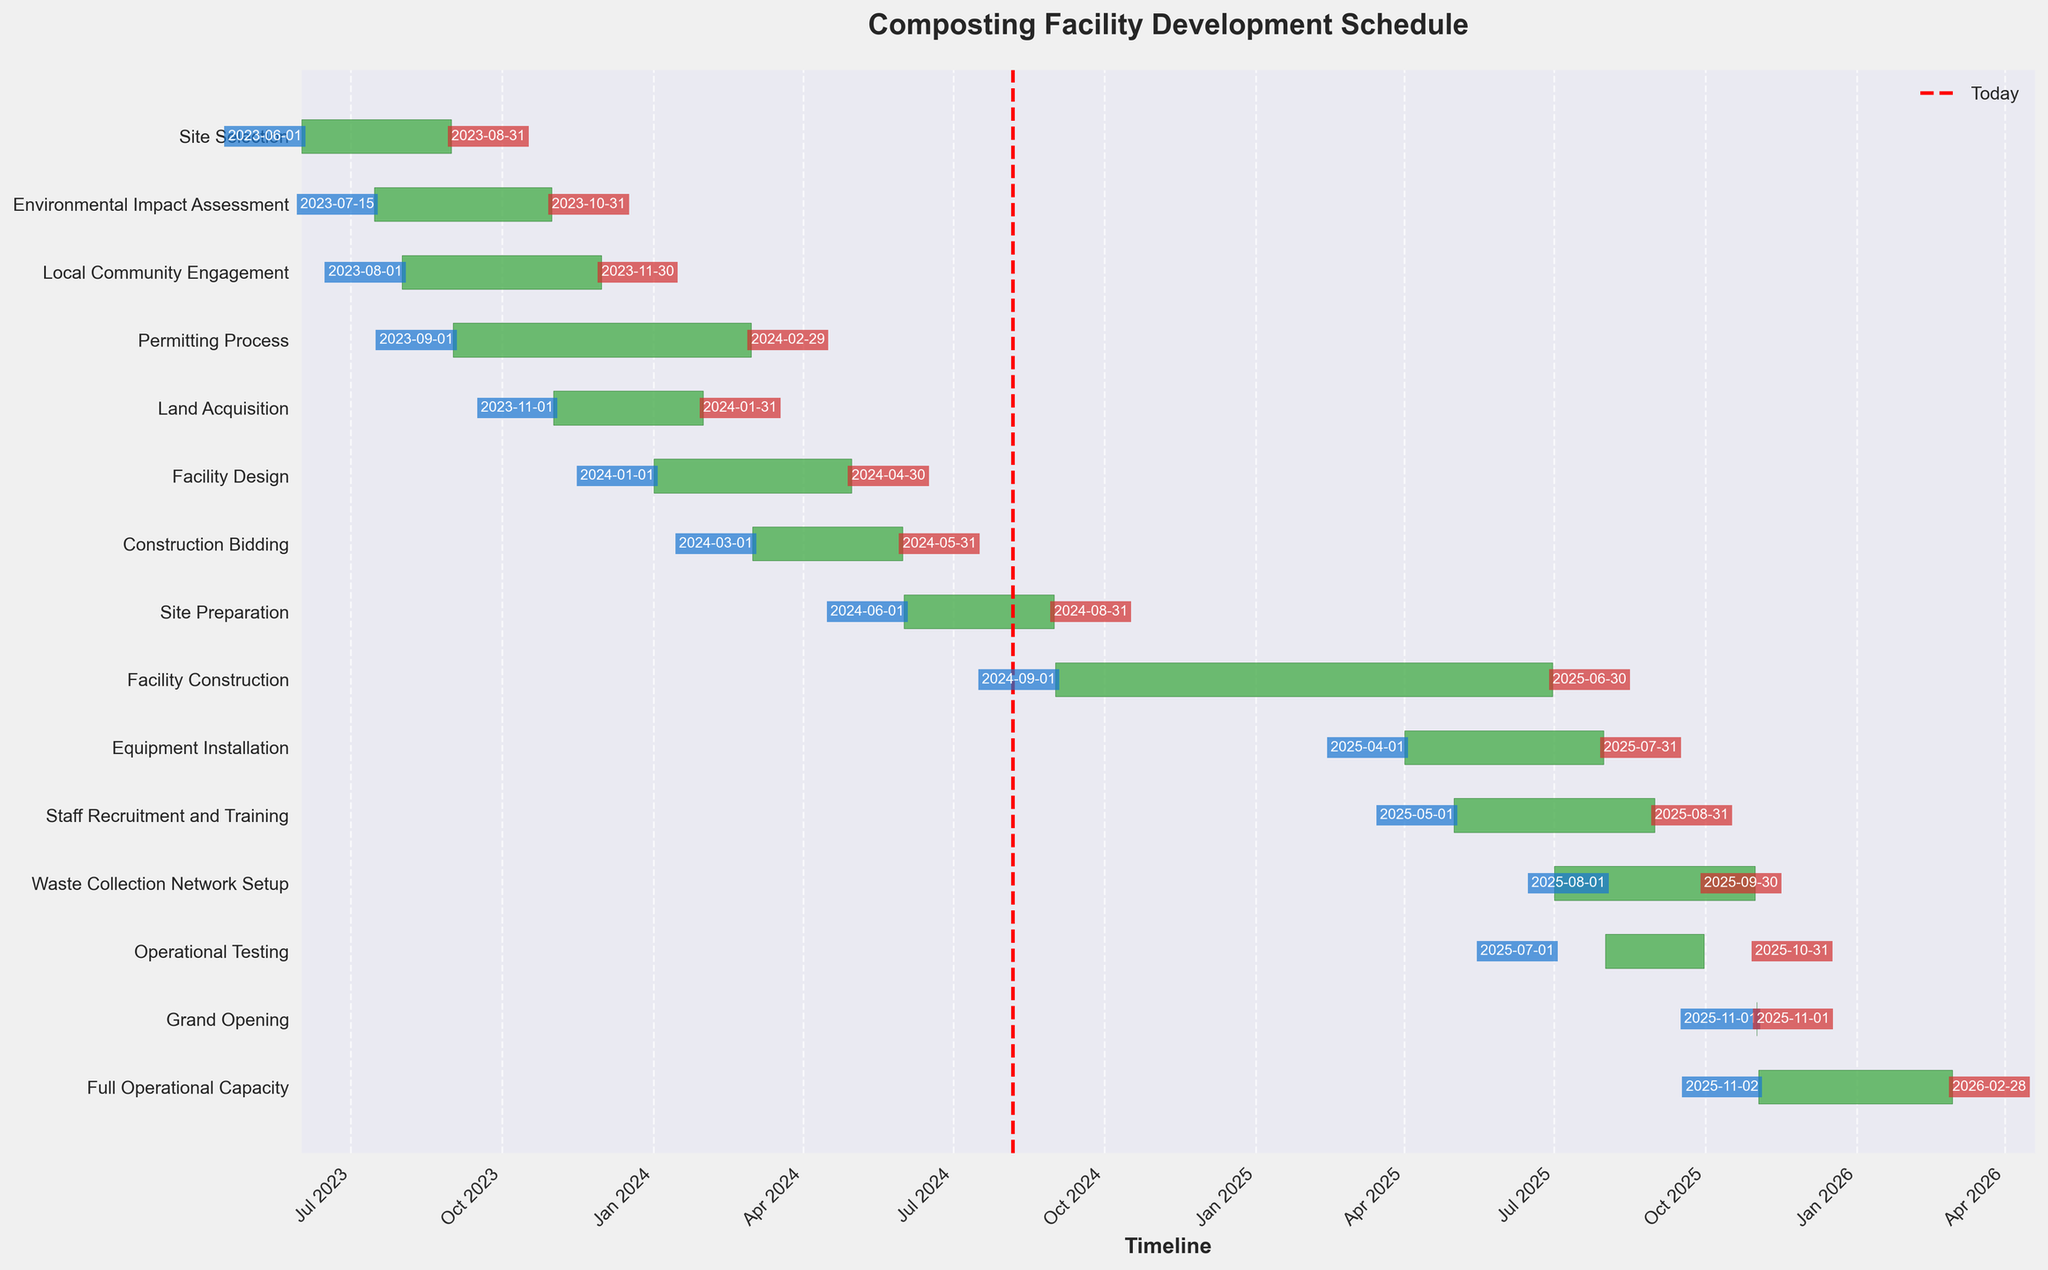What's the title of the Gantt chart? The title is usually found at the top of the chart and summarizes the purpose or content of the chart.
Answer: Composting Facility Development Schedule How many tasks are included in the schedule? Each bar in the chart represents a task. Counting the bars gives the total number of tasks.
Answer: 14 When does the Site Selection task begin and end? The start and end dates are labeled at the beginning and end of the related bar for the Site Selection task.
Answer: Begins on 2023-06-01, ends on 2023-08-31 Which task takes the longest to complete? The task with the widest bar, representing the longest duration from start to end date, indicates which task takes the longest.
Answer: Facility Construction Do any tasks start before the Environmental Impact Assessment ends? Looking at the end date of the Environmental Impact Assessment and comparing it with the start dates of subsequent tasks will answer this question.
Answer: Yes Which task overlaps with both the Permitting Process and Land Acquisition stages? By checking where the bars for these tasks overlap in the timeline, you can identify tasks that coexist in their timeframes with both.
Answer: Local Community Engagement How many months are between the start of Site Selection and the end of Staff Recruitment and Training? Calculate the time difference between the start date of Site Selection and the end date of Staff Recruitment and Training.
Answer: 27 months Which tasks are running concurrently with Site Preparation? Identify the tasks whose bars overlap with the timeframe of Site Preparation.
Answer: Construction Bidding, Facility Construction When is the grand opening scheduled to take place? The grand opening is a specific event, easily identified by its placement on the Gantt chart.
Answer: 2025-11-01 Are there any tasks that start on the same day? If so, which ones? Compare start dates across all tasks to see if any coincide.
Answer: No tasks start on the exact same day 